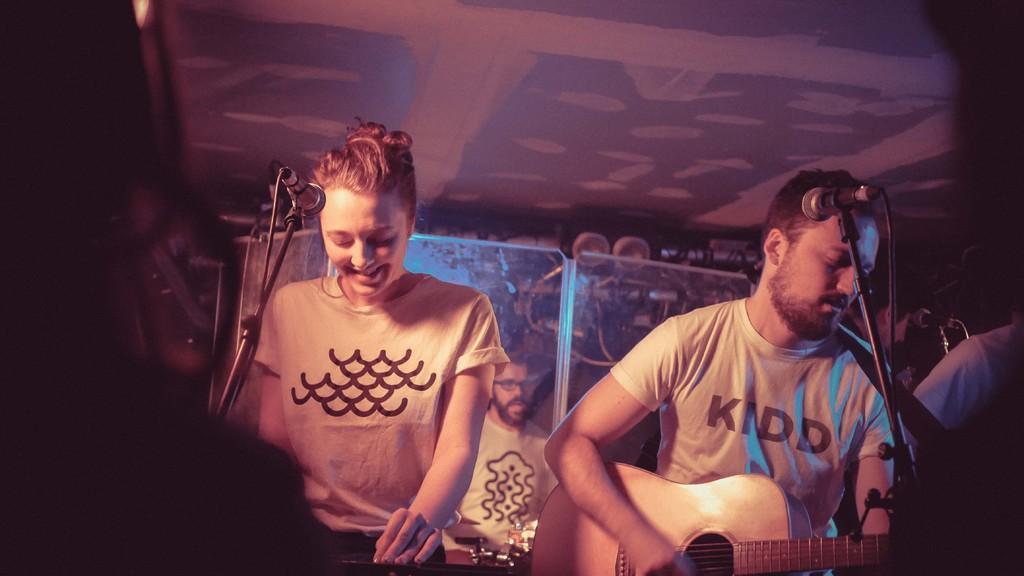In one or two sentences, can you explain what this image depicts? This woman is standing in-front of the mic. This person is holding a guitar, in-front of him there is a mic and mic holder. Far a person is standing and playing a musical instrument. 